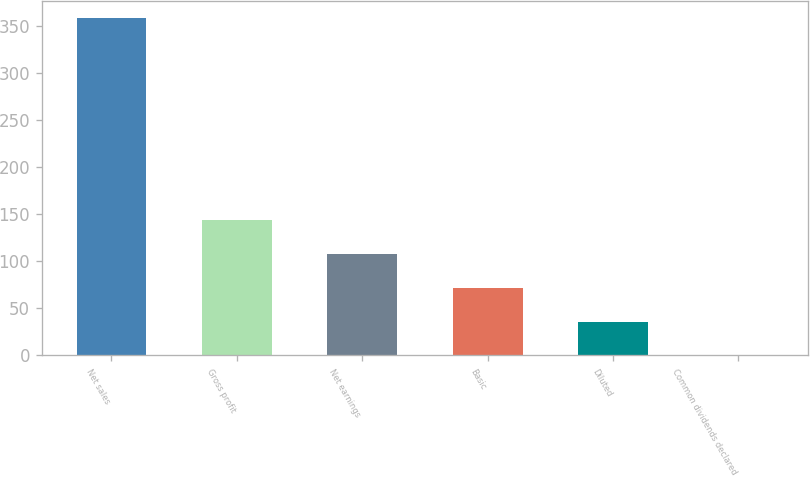Convert chart to OTSL. <chart><loc_0><loc_0><loc_500><loc_500><bar_chart><fcel>Net sales<fcel>Gross profit<fcel>Net earnings<fcel>Basic<fcel>Diluted<fcel>Common dividends declared<nl><fcel>358.5<fcel>143.5<fcel>107.66<fcel>71.82<fcel>35.98<fcel>0.14<nl></chart> 